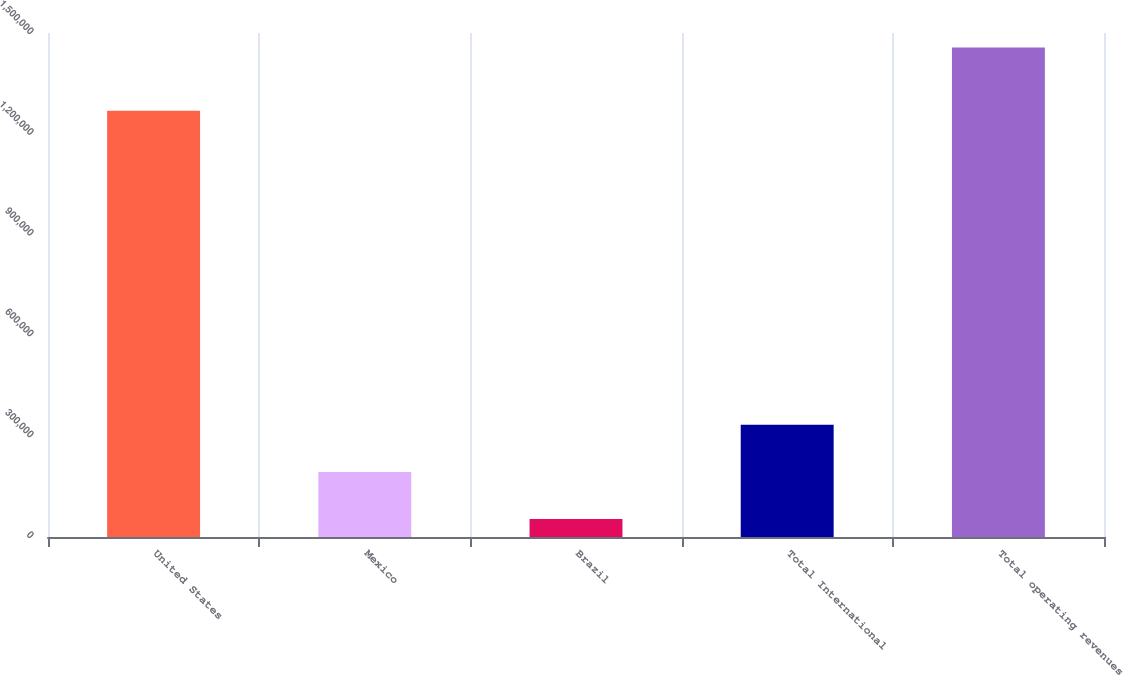<chart> <loc_0><loc_0><loc_500><loc_500><bar_chart><fcel>United States<fcel>Mexico<fcel>Brazil<fcel>Total International<fcel>Total operating revenues<nl><fcel>1.26832e+06<fcel>193790<fcel>53478<fcel>334101<fcel>1.45659e+06<nl></chart> 